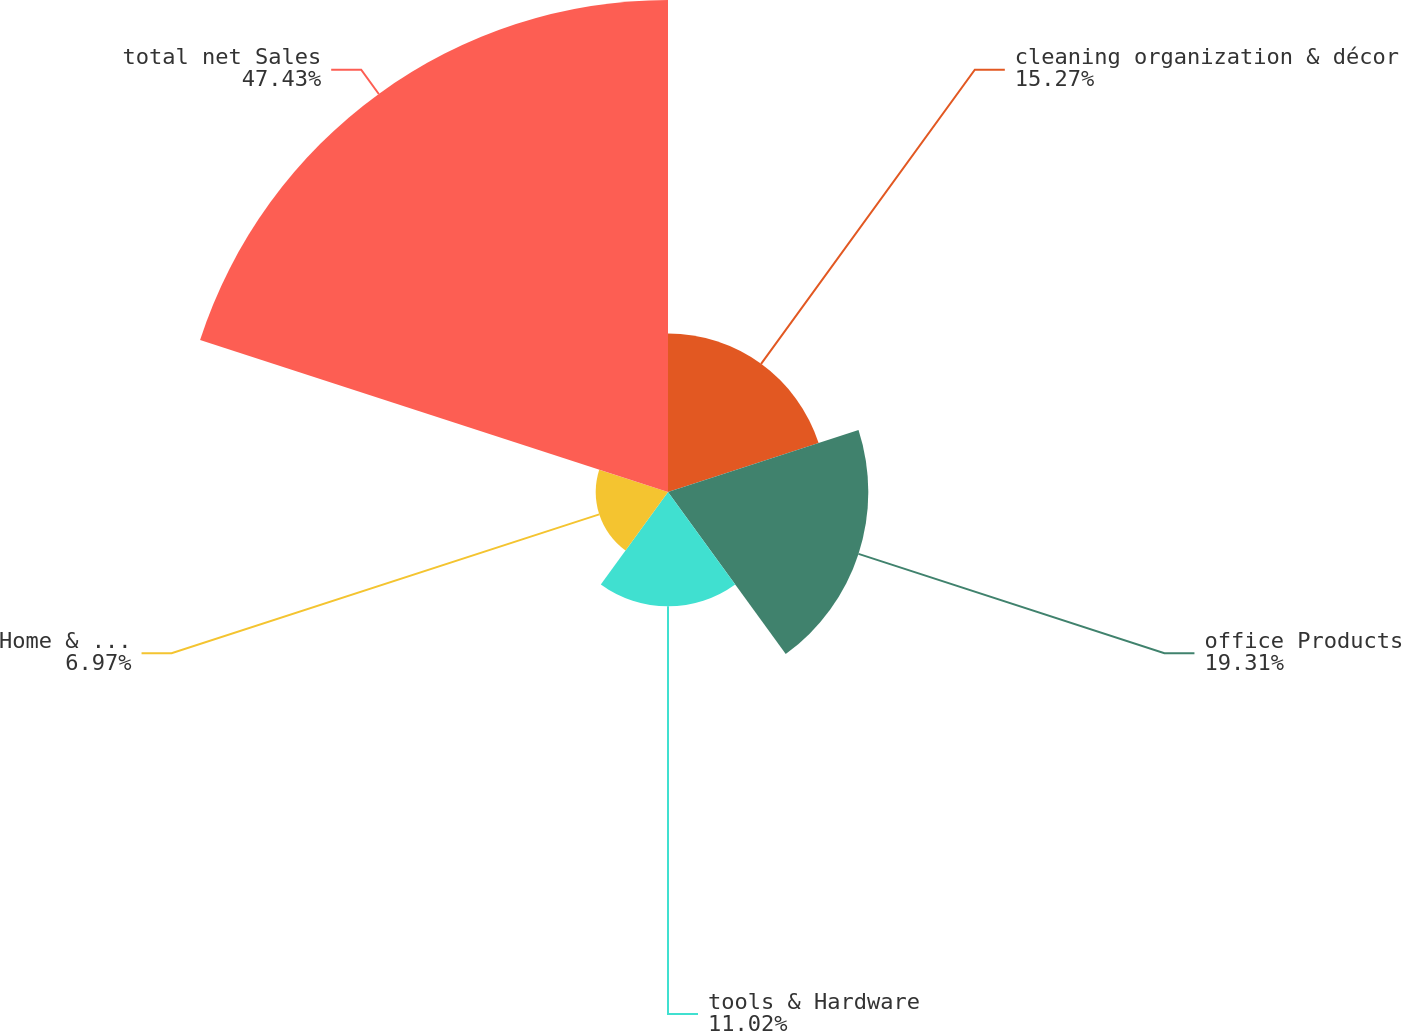Convert chart to OTSL. <chart><loc_0><loc_0><loc_500><loc_500><pie_chart><fcel>cleaning organization & décor<fcel>office Products<fcel>tools & Hardware<fcel>Home & Family<fcel>total net Sales<nl><fcel>15.27%<fcel>19.31%<fcel>11.02%<fcel>6.97%<fcel>47.43%<nl></chart> 